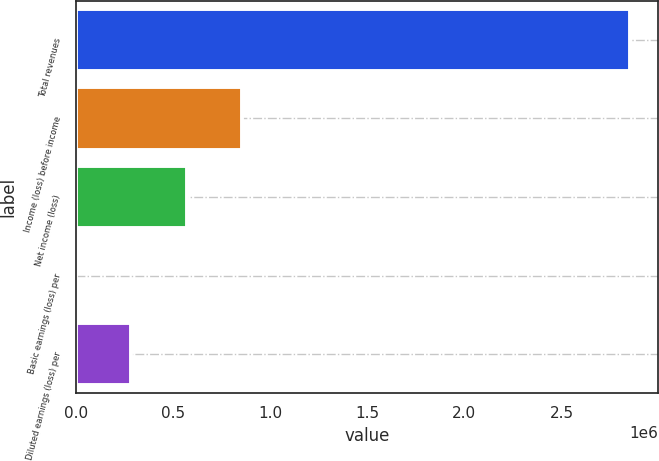<chart> <loc_0><loc_0><loc_500><loc_500><bar_chart><fcel>Total revenues<fcel>Income (loss) before income<fcel>Net income (loss)<fcel>Basic earnings (loss) per<fcel>Diluted earnings (loss) per<nl><fcel>2.85503e+06<fcel>856510<fcel>571006<fcel>0.01<fcel>285503<nl></chart> 